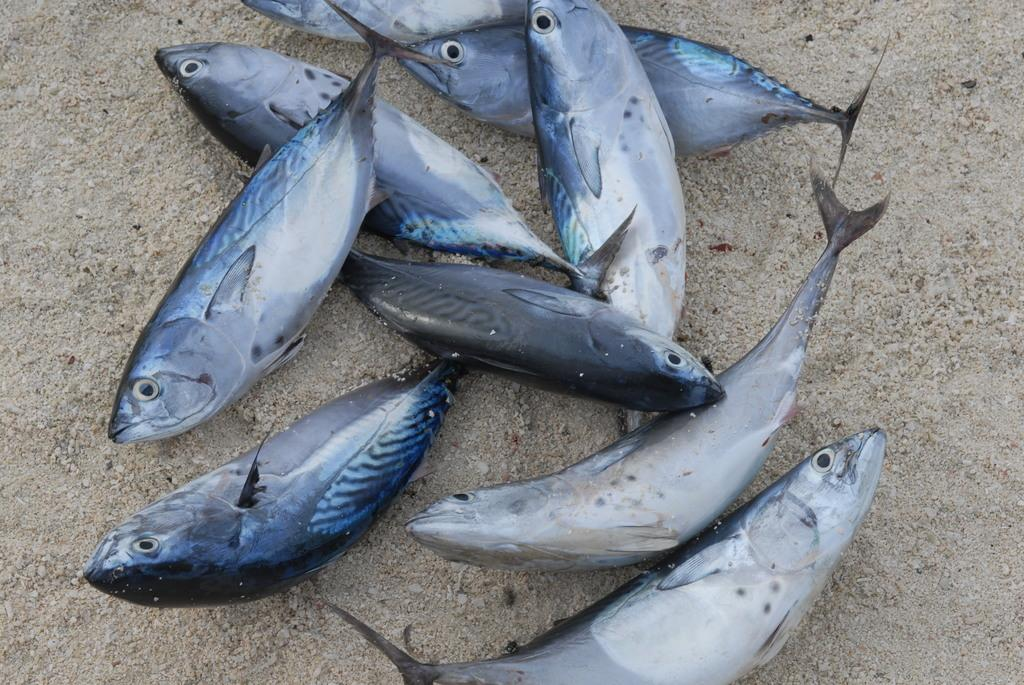What animals can be seen in the image with the person walking? There is a dog being walked by the person in the image. What is the person holding while walking the dog? The person is holding a leash to walk the dog. What is the person doing in the image with the book? The person is reading the book in the image. What might the person be using to protect themselves from the sun or rain? The person holding an umbrella in the image might be using it for protection from the sun or rain. What type of net can be seen in the image with the group of children playing in the sand? There is no net present in the image with the group of children playing in the sand. What club is the person holding while reading the book? The person in the image reading the book is not holding any club. 